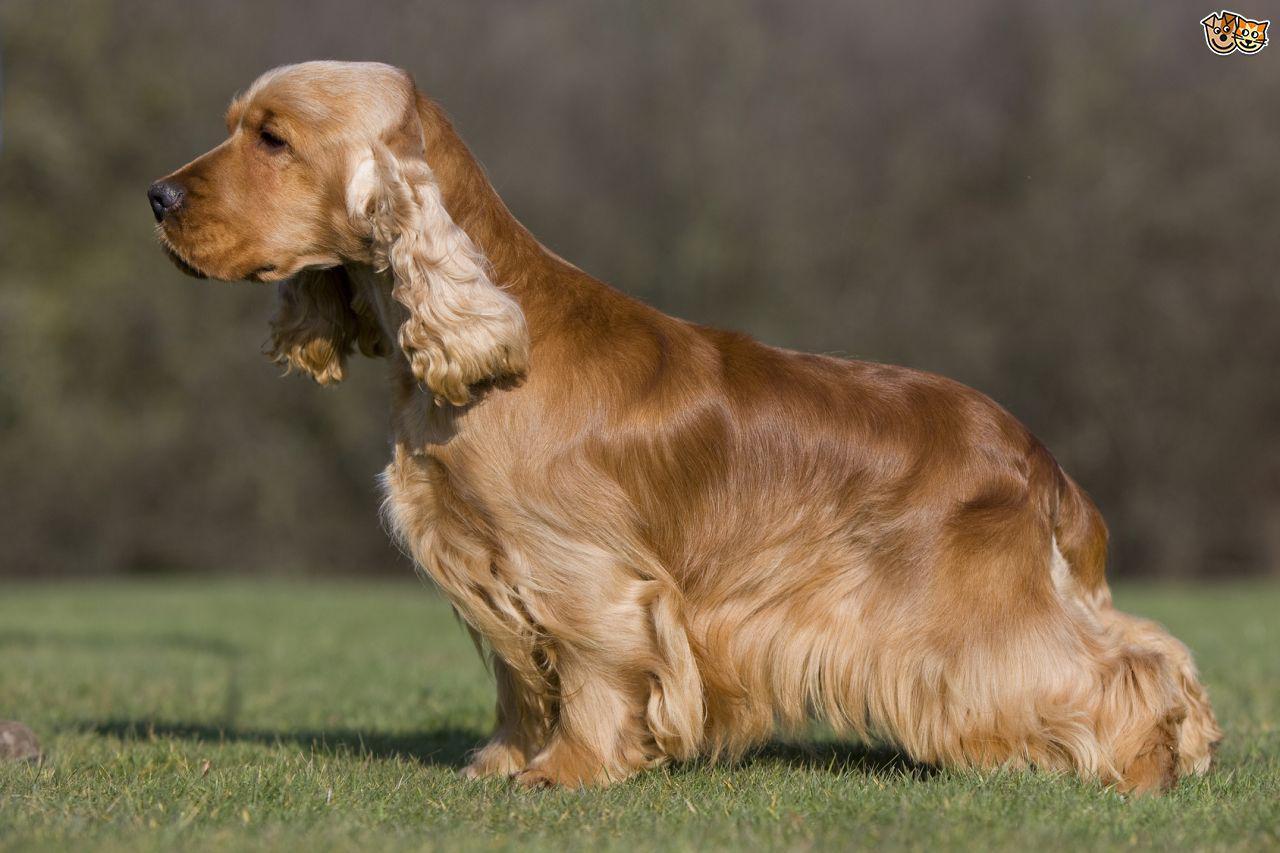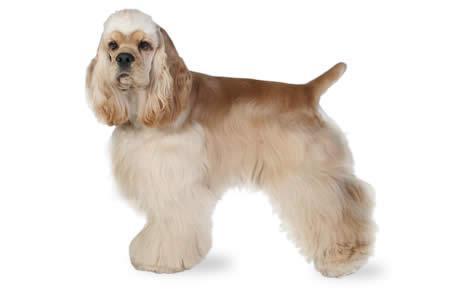The first image is the image on the left, the second image is the image on the right. For the images displayed, is the sentence "The left image shows a spaniel with its body in profile." factually correct? Answer yes or no. Yes. 